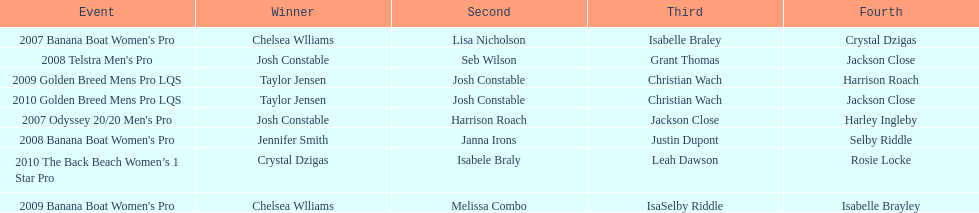In what two races did chelsea williams earn the same rank? 2007 Banana Boat Women's Pro, 2009 Banana Boat Women's Pro. 